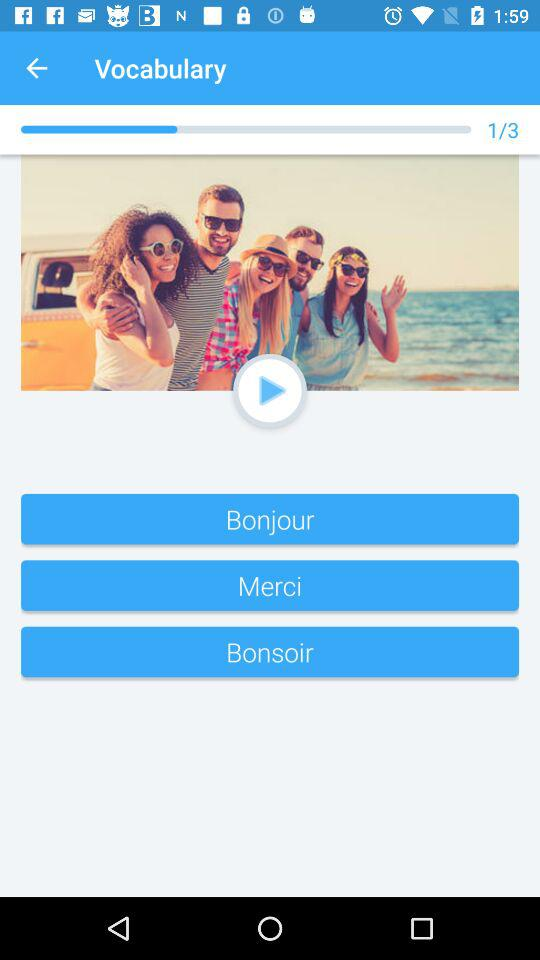What is the application name? The application name is "Vocabulary". 